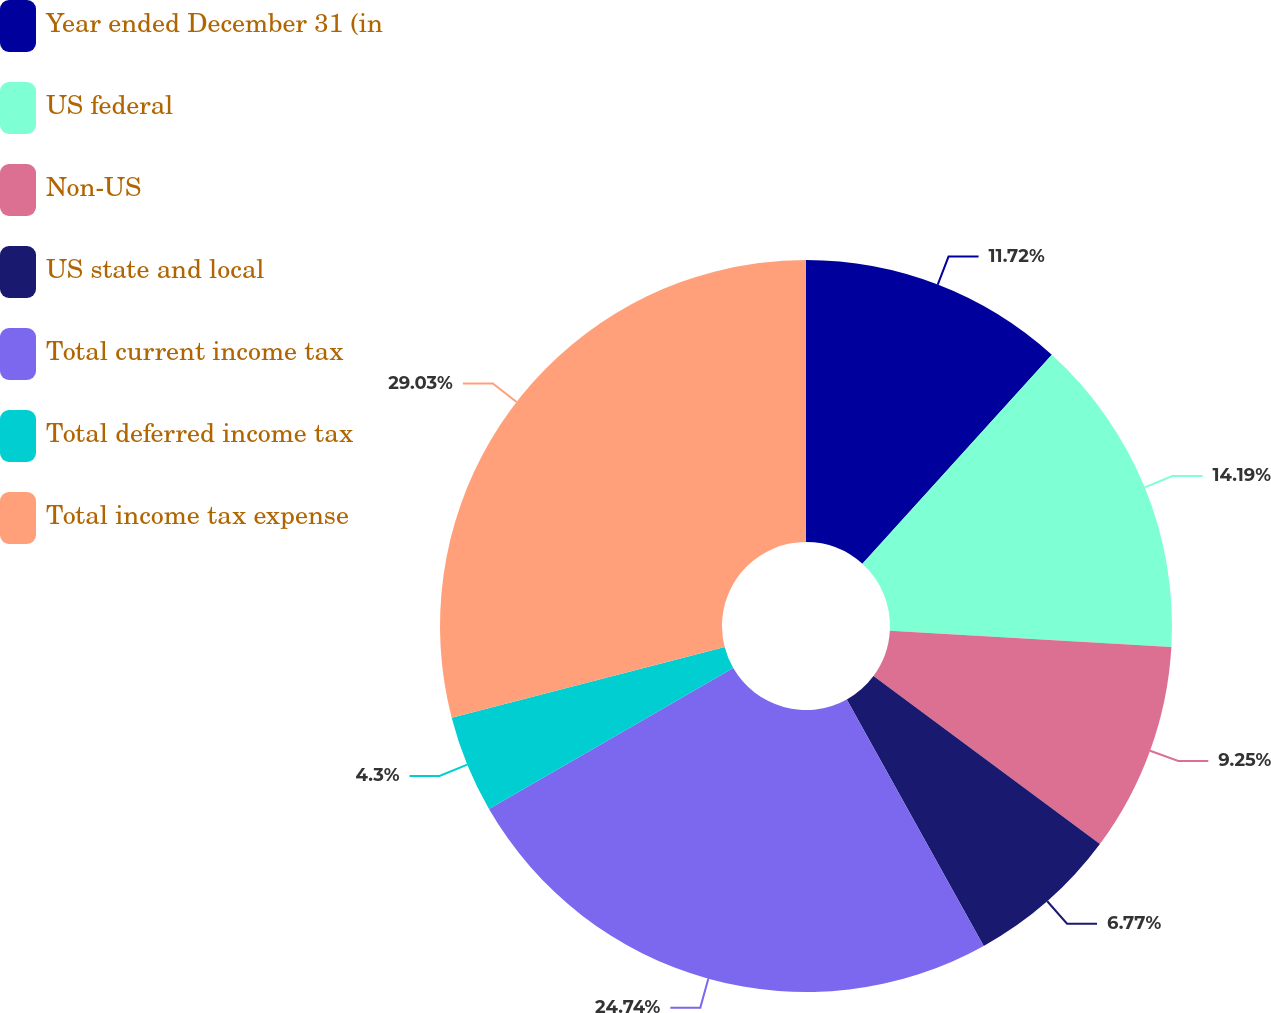Convert chart. <chart><loc_0><loc_0><loc_500><loc_500><pie_chart><fcel>Year ended December 31 (in<fcel>US federal<fcel>Non-US<fcel>US state and local<fcel>Total current income tax<fcel>Total deferred income tax<fcel>Total income tax expense<nl><fcel>11.72%<fcel>14.19%<fcel>9.25%<fcel>6.77%<fcel>24.74%<fcel>4.3%<fcel>29.03%<nl></chart> 